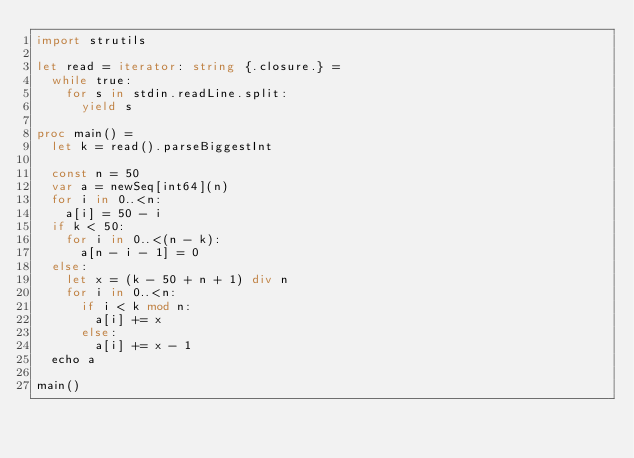<code> <loc_0><loc_0><loc_500><loc_500><_Nim_>import strutils

let read = iterator: string {.closure.} =
  while true:
    for s in stdin.readLine.split:
      yield s

proc main() =
  let k = read().parseBiggestInt

  const n = 50
  var a = newSeq[int64](n)
  for i in 0..<n:
    a[i] = 50 - i
  if k < 50:
    for i in 0..<(n - k):
      a[n - i - 1] = 0
  else:
    let x = (k - 50 + n + 1) div n
    for i in 0..<n:
      if i < k mod n:
        a[i] += x
      else:
        a[i] += x - 1
  echo a

main()</code> 